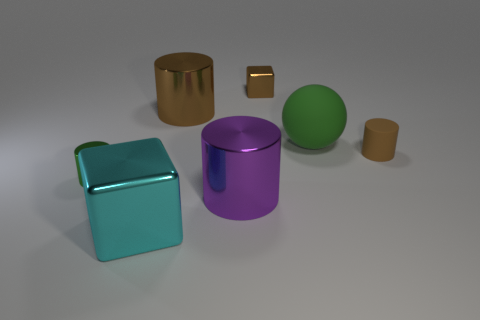Subtract all brown shiny cylinders. How many cylinders are left? 3 Add 2 tiny cubes. How many objects exist? 9 Subtract all green cubes. How many brown cylinders are left? 2 Subtract all brown cubes. How many cubes are left? 1 Subtract 0 cyan balls. How many objects are left? 7 Subtract all cylinders. How many objects are left? 3 Subtract 2 cylinders. How many cylinders are left? 2 Subtract all purple balls. Subtract all brown blocks. How many balls are left? 1 Subtract all big cyan metal objects. Subtract all large green rubber balls. How many objects are left? 5 Add 3 small brown rubber cylinders. How many small brown rubber cylinders are left? 4 